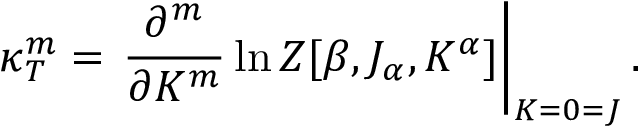<formula> <loc_0><loc_0><loc_500><loc_500>\kappa _ { T } ^ { m } = \frac { \partial ^ { m } } { \partial K ^ { m } } \ln Z [ \beta , J _ { \alpha } , K ^ { \alpha } ] \right | _ { K = 0 = J } .</formula> 